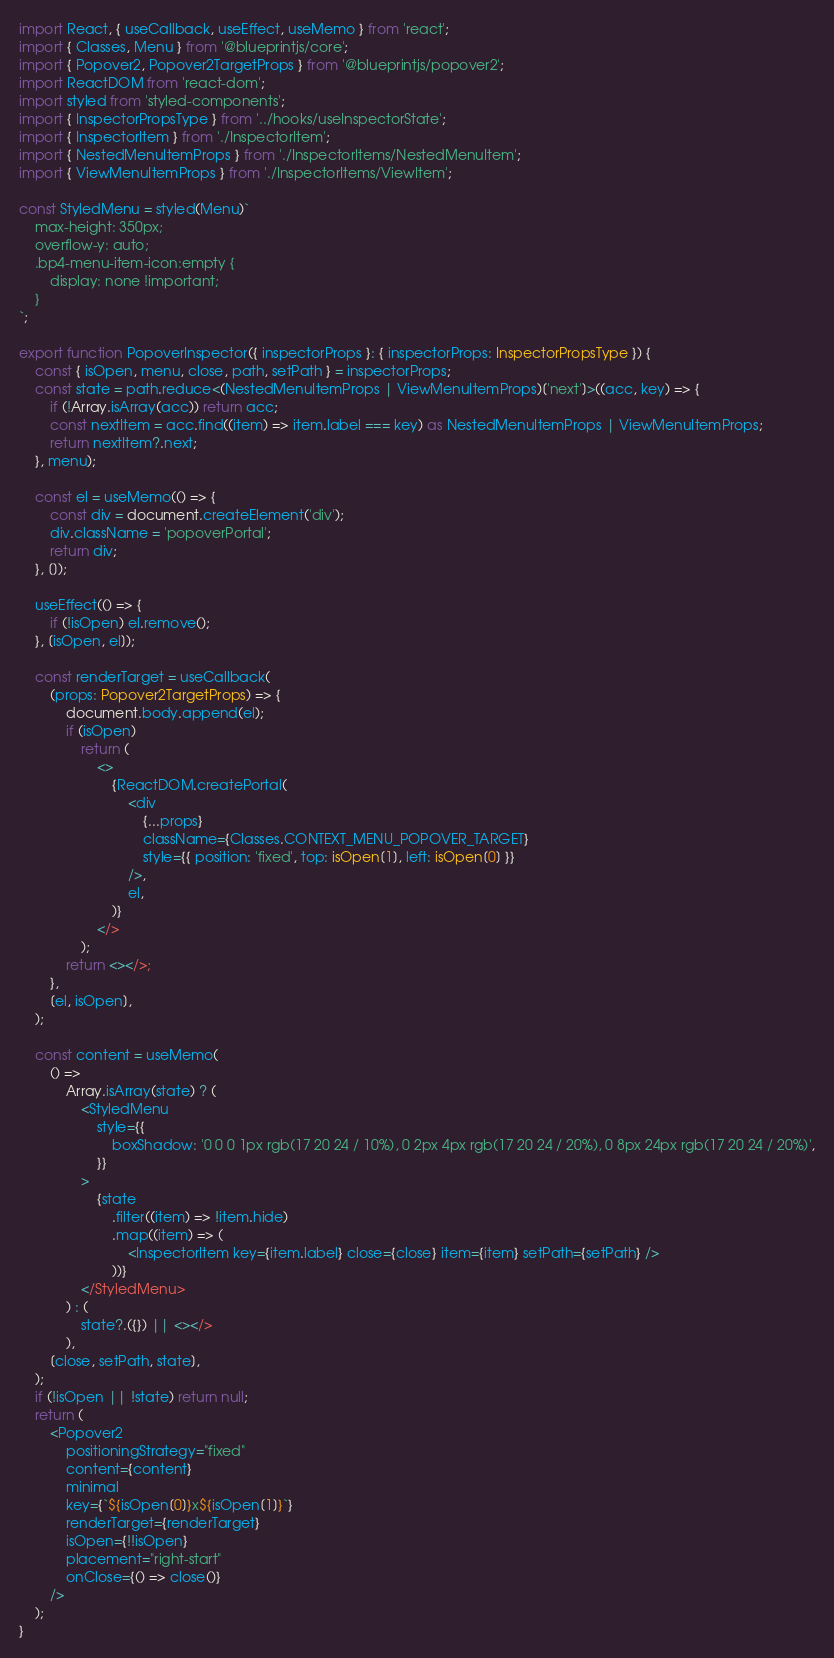<code> <loc_0><loc_0><loc_500><loc_500><_TypeScript_>import React, { useCallback, useEffect, useMemo } from 'react';
import { Classes, Menu } from '@blueprintjs/core';
import { Popover2, Popover2TargetProps } from '@blueprintjs/popover2';
import ReactDOM from 'react-dom';
import styled from 'styled-components';
import { InspectorPropsType } from '../hooks/useInspectorState';
import { InspectorItem } from './InspectorItem';
import { NestedMenuItemProps } from './InspectorItems/NestedMenuItem';
import { ViewMenuItemProps } from './InspectorItems/ViewItem';

const StyledMenu = styled(Menu)`
	max-height: 350px;
	overflow-y: auto;
	.bp4-menu-item-icon:empty {
		display: none !important;
	}
`;

export function PopoverInspector({ inspectorProps }: { inspectorProps: InspectorPropsType }) {
	const { isOpen, menu, close, path, setPath } = inspectorProps;
	const state = path.reduce<(NestedMenuItemProps | ViewMenuItemProps)['next']>((acc, key) => {
		if (!Array.isArray(acc)) return acc;
		const nextItem = acc.find((item) => item.label === key) as NestedMenuItemProps | ViewMenuItemProps;
		return nextItem?.next;
	}, menu);

	const el = useMemo(() => {
		const div = document.createElement('div');
		div.className = 'popoverPortal';
		return div;
	}, []);

	useEffect(() => {
		if (!isOpen) el.remove();
	}, [isOpen, el]);

	const renderTarget = useCallback(
		(props: Popover2TargetProps) => {
			document.body.append(el);
			if (isOpen)
				return (
					<>
						{ReactDOM.createPortal(
							<div
								{...props}
								className={Classes.CONTEXT_MENU_POPOVER_TARGET}
								style={{ position: 'fixed', top: isOpen[1], left: isOpen[0] }}
							/>,
							el,
						)}
					</>
				);
			return <></>;
		},
		[el, isOpen],
	);

	const content = useMemo(
		() =>
			Array.isArray(state) ? (
				<StyledMenu
					style={{
						boxShadow: '0 0 0 1px rgb(17 20 24 / 10%), 0 2px 4px rgb(17 20 24 / 20%), 0 8px 24px rgb(17 20 24 / 20%)',
					}}
				>
					{state
						.filter((item) => !item.hide)
						.map((item) => (
							<InspectorItem key={item.label} close={close} item={item} setPath={setPath} />
						))}
				</StyledMenu>
			) : (
				state?.({}) || <></>
			),
		[close, setPath, state],
	);
	if (!isOpen || !state) return null;
	return (
		<Popover2
			positioningStrategy="fixed"
			content={content}
			minimal
			key={`${isOpen[0]}x${isOpen[1]}`}
			renderTarget={renderTarget}
			isOpen={!!isOpen}
			placement="right-start"
			onClose={() => close()}
		/>
	);
}
</code> 